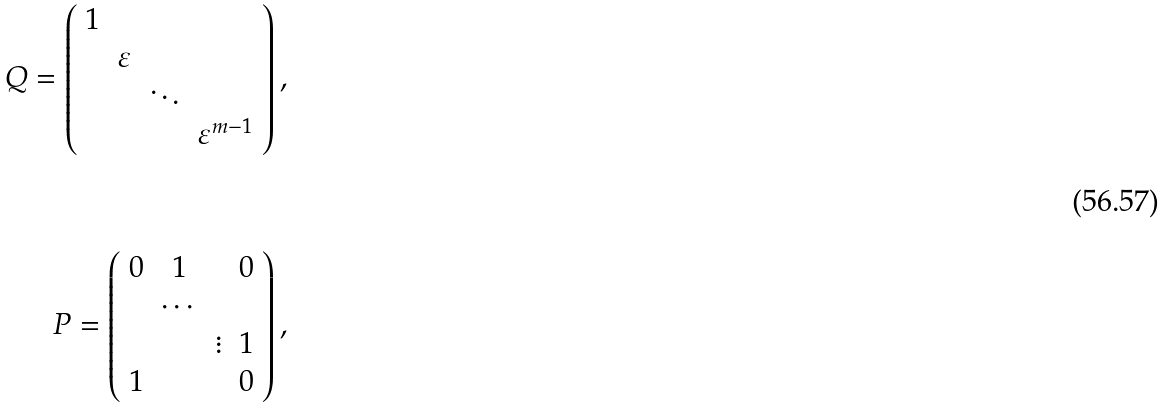<formula> <loc_0><loc_0><loc_500><loc_500>Q = \left ( \begin{array} { c c c c } 1 & & & \\ & \varepsilon & & \\ & & \ddots & \\ & & & \varepsilon ^ { m - 1 } \end{array} \right ) , \\ \\ \\ \ P = \left ( \begin{array} { c c c c } 0 & 1 & & 0 \\ & \cdots & & \\ & & \vdots & 1 \\ 1 & & & 0 \end{array} \right ) ,</formula> 